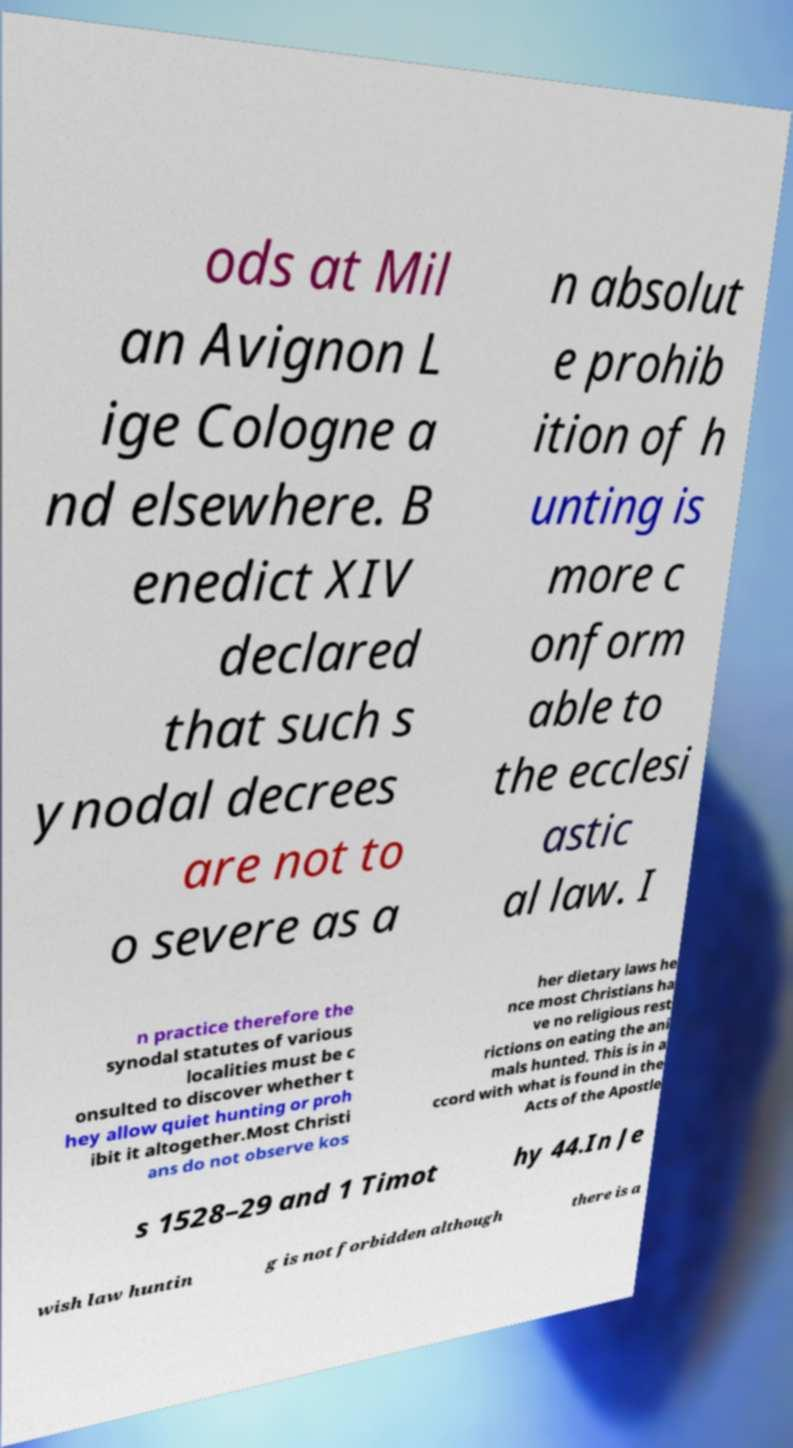Could you assist in decoding the text presented in this image and type it out clearly? ods at Mil an Avignon L ige Cologne a nd elsewhere. B enedict XIV declared that such s ynodal decrees are not to o severe as a n absolut e prohib ition of h unting is more c onform able to the ecclesi astic al law. I n practice therefore the synodal statutes of various localities must be c onsulted to discover whether t hey allow quiet hunting or proh ibit it altogether.Most Christi ans do not observe kos her dietary laws he nce most Christians ha ve no religious rest rictions on eating the ani mals hunted. This is in a ccord with what is found in the Acts of the Apostle s 1528–29 and 1 Timot hy 44.In Je wish law huntin g is not forbidden although there is a 